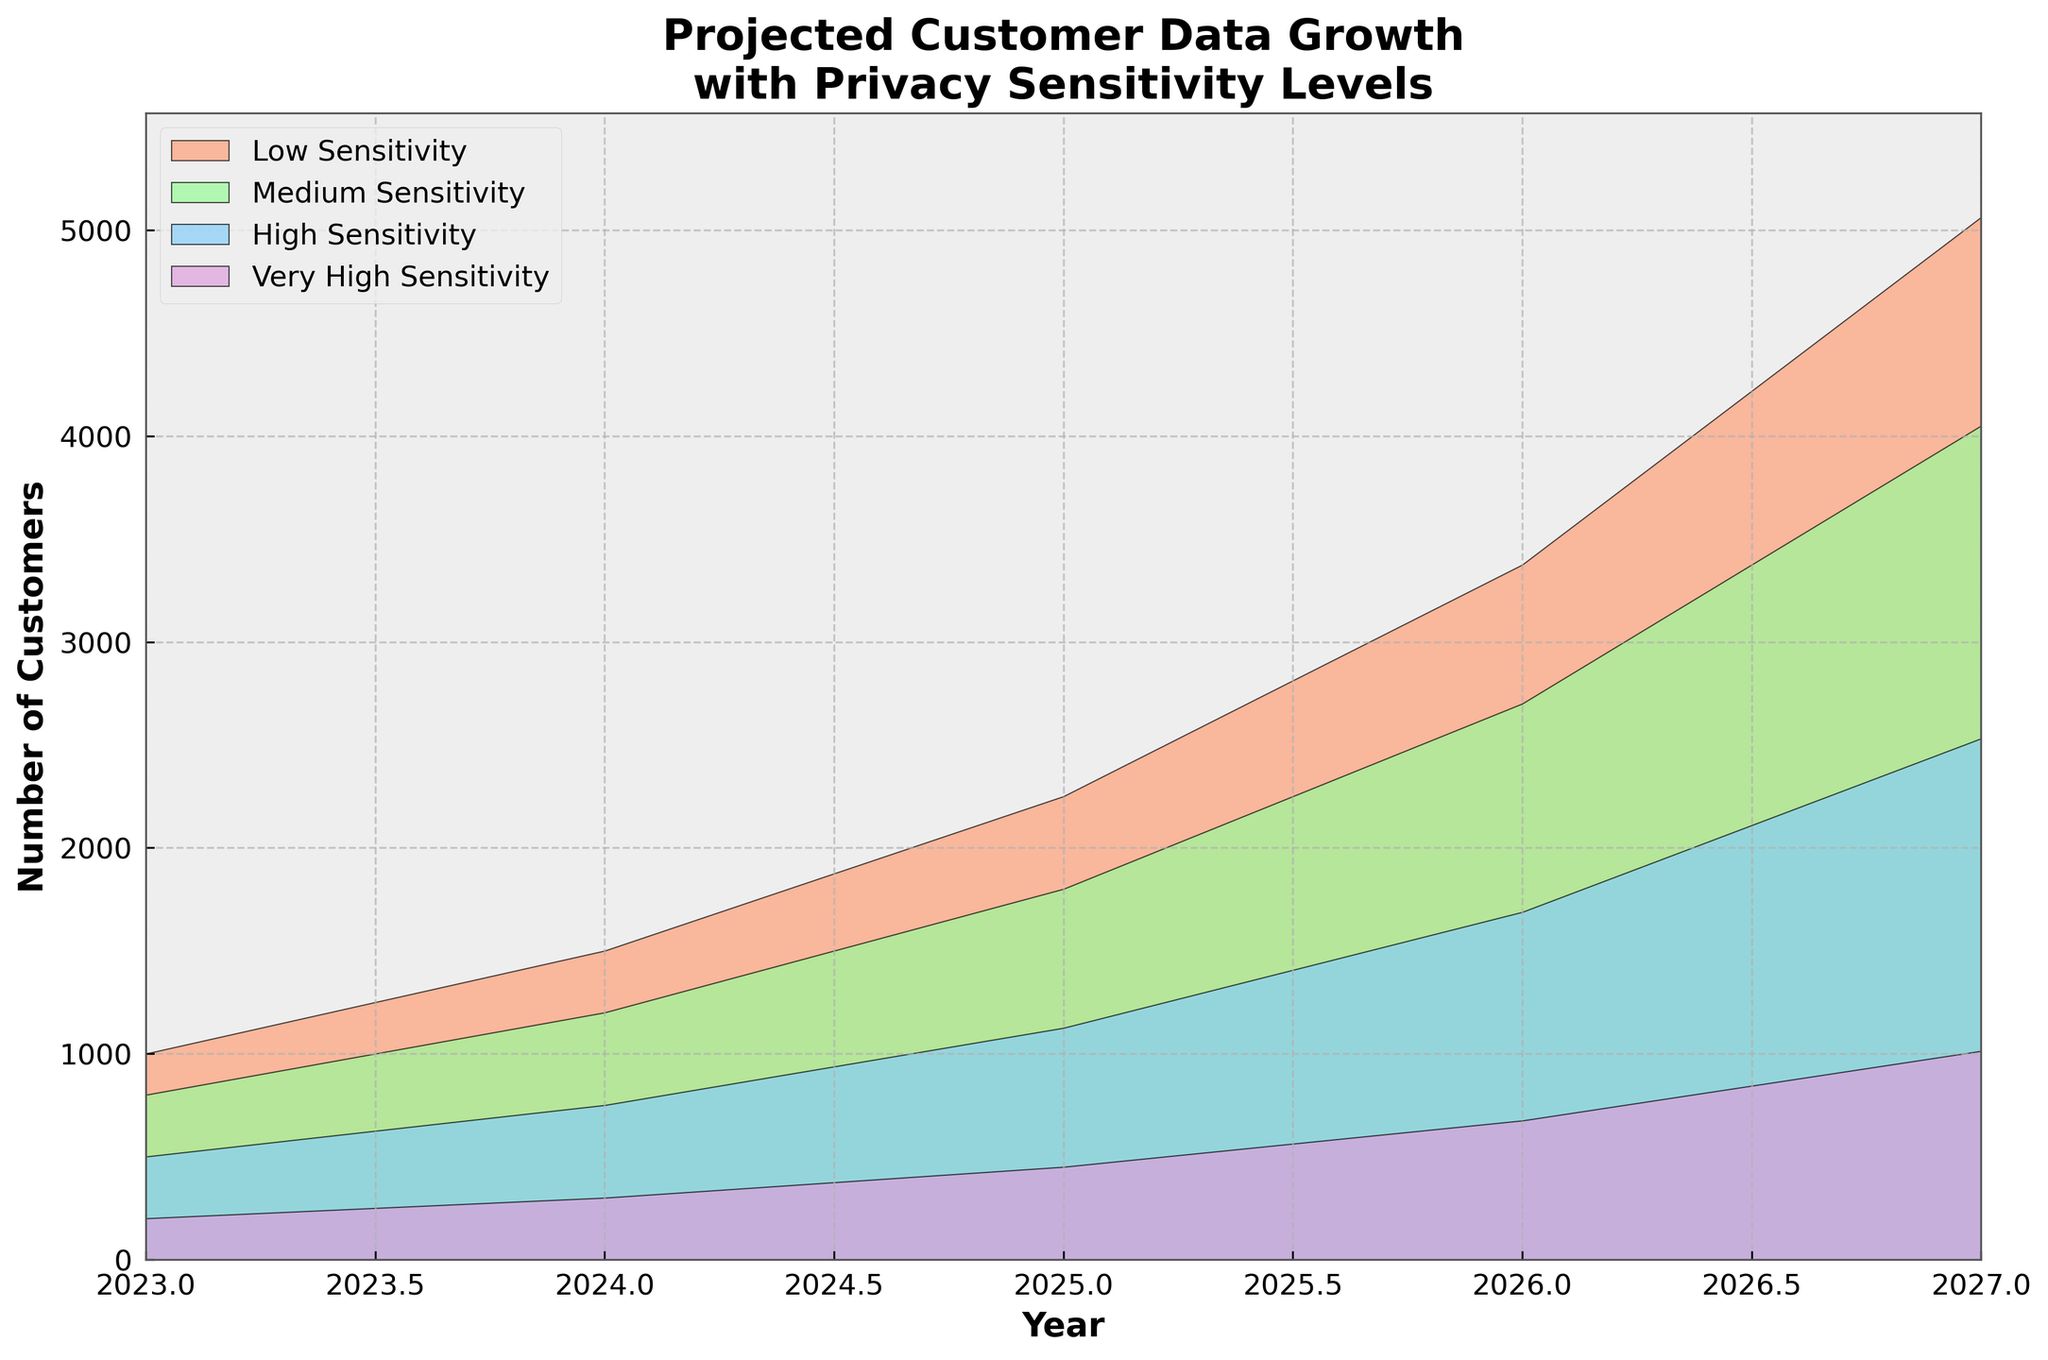What's the title of the figure? The title is displayed at the top of the figure. It should summarize the main topic being visualized.
Answer: Projected Customer Data Growth with Privacy Sensitivity Levels How many sensitivity levels are represented in the chart? By observing the legend, we can see each sensitivity level is represented by a different color. Count them to find the total number.
Answer: Four What is the projected number of customers for High Sensitivity data in 2025? Locate the "High Sensitivity" area for the year 2025 on the x-axis, then read the corresponding value on the y-axis.
Answer: 1125 By how much does the projected number of customers with Medium Sensitivity data change from 2023 to 2027? Find the values for Medium Sensitivity data in 2023 and 2027, then calculate the difference: 4050 - 800 = 3250.
Answer: 3250 Which year shows the highest projected number of customers across all sensitivity levels? Compare the total sum of values for all sensitivity levels across years. The highest sum indicates the year with the maximum projected customers.
Answer: 2027 Which sensitivity level has the smallest projected customer growth over the 5 years? Calculate the growth for each level from 2023 to 2027 and compare: 
Low: 5063 - 1000 = 4063 
Medium: 4050 - 800 = 3250 
High: 2531 - 500 = 2031 
Very High: 1013 - 200 = 813 
The Very High Sensitivity has the smallest growth.
Answer: Very High Sensitivity What's the total projected number of customers for all sensitivity levels combined in 2026? Sum the projected number of customers for each sensitivity level in 2026: 
3375 (Low) + 2700 (Medium) + 1688 (High) + 675 (Very High) = 8438.
Answer: 8438 In which year does the number of customers with Low Sensitivity data exceed 2000? Following the Low Sensitivity data trend along the years, the number surpasses 2000 in 2025.
Answer: 2025 How do the projected numbers for customers with Very High Sensitivity data compare to those with High Sensitivity data in 2024? Compare the values of Very High Sensitivity (300) and High Sensitivity (750) data in 2024. Very High is less than High.
Answer: Very High is less 